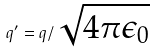<formula> <loc_0><loc_0><loc_500><loc_500>q ^ { \prime } = q / \sqrt { 4 \pi \epsilon _ { 0 } }</formula> 